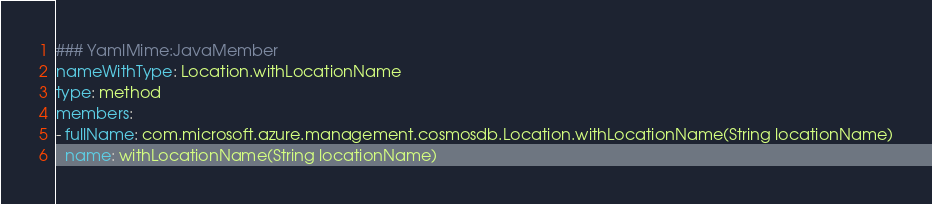Convert code to text. <code><loc_0><loc_0><loc_500><loc_500><_YAML_>### YamlMime:JavaMember
nameWithType: Location.withLocationName
type: method
members:
- fullName: com.microsoft.azure.management.cosmosdb.Location.withLocationName(String locationName)
  name: withLocationName(String locationName)</code> 